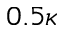<formula> <loc_0><loc_0><loc_500><loc_500>0 . 5 \kappa</formula> 